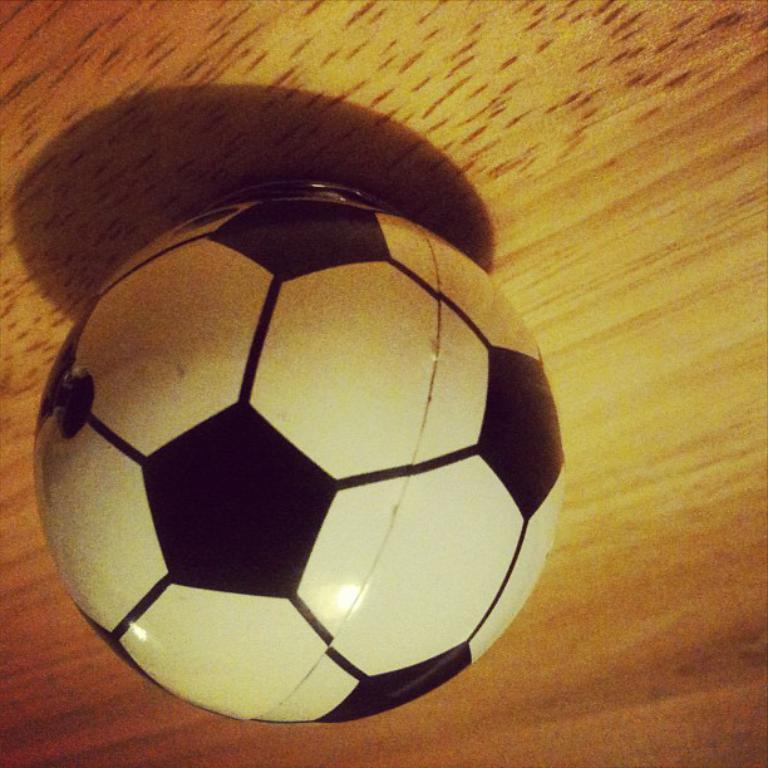What is the primary object in the image? There is a white and black color ball in the image. What can be inferred about the surface the ball is on? The ball is on a surface that resembles a table. How many apples are on the table next to the spade in the image? There is no table, spade, or apples present in the image; it only features a white and black color ball on a surface that resembles a table. 